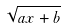Convert formula to latex. <formula><loc_0><loc_0><loc_500><loc_500>\sqrt { a x + b }</formula> 